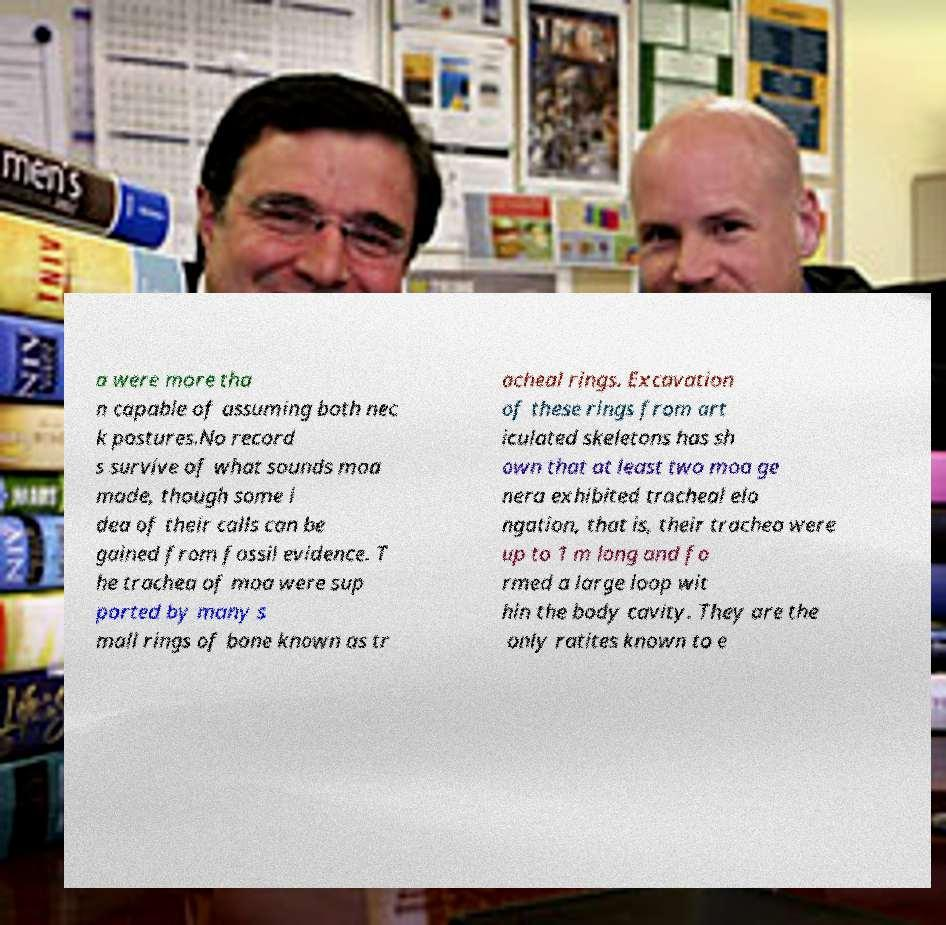There's text embedded in this image that I need extracted. Can you transcribe it verbatim? a were more tha n capable of assuming both nec k postures.No record s survive of what sounds moa made, though some i dea of their calls can be gained from fossil evidence. T he trachea of moa were sup ported by many s mall rings of bone known as tr acheal rings. Excavation of these rings from art iculated skeletons has sh own that at least two moa ge nera exhibited tracheal elo ngation, that is, their trachea were up to 1 m long and fo rmed a large loop wit hin the body cavity. They are the only ratites known to e 